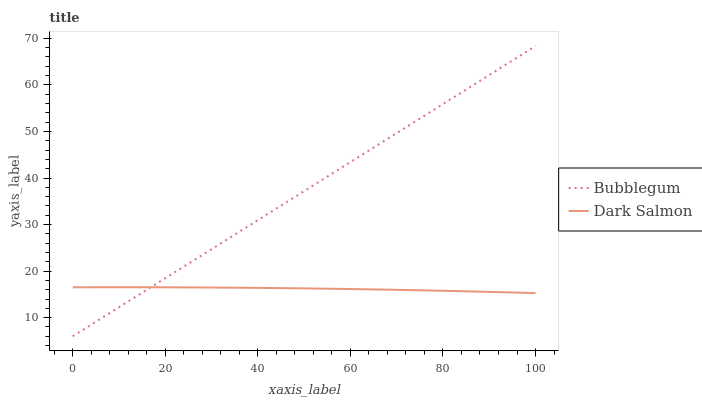Does Dark Salmon have the minimum area under the curve?
Answer yes or no. Yes. Does Bubblegum have the maximum area under the curve?
Answer yes or no. Yes. Does Bubblegum have the minimum area under the curve?
Answer yes or no. No. Is Bubblegum the smoothest?
Answer yes or no. Yes. Is Dark Salmon the roughest?
Answer yes or no. Yes. Is Bubblegum the roughest?
Answer yes or no. No. Does Bubblegum have the lowest value?
Answer yes or no. Yes. Does Bubblegum have the highest value?
Answer yes or no. Yes. Does Bubblegum intersect Dark Salmon?
Answer yes or no. Yes. Is Bubblegum less than Dark Salmon?
Answer yes or no. No. Is Bubblegum greater than Dark Salmon?
Answer yes or no. No. 